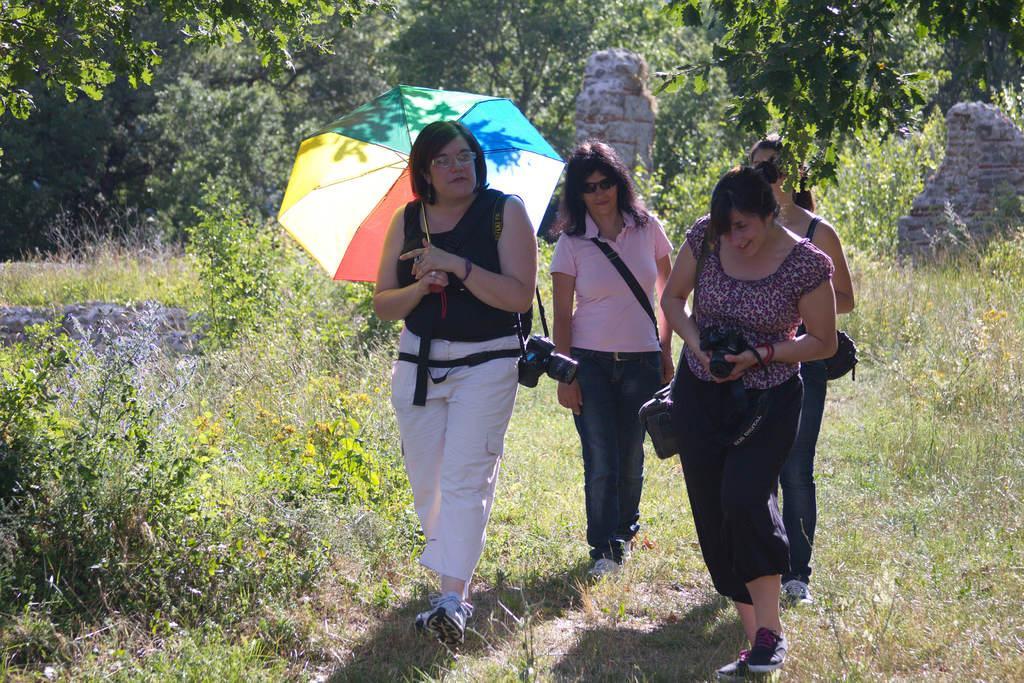Could you give a brief overview of what you see in this image? In this image in the center there are some people who are walking and one woman is holding an umbrella and one woman is holding a camera. In the background there are some trees and at the bottom there is grass. 